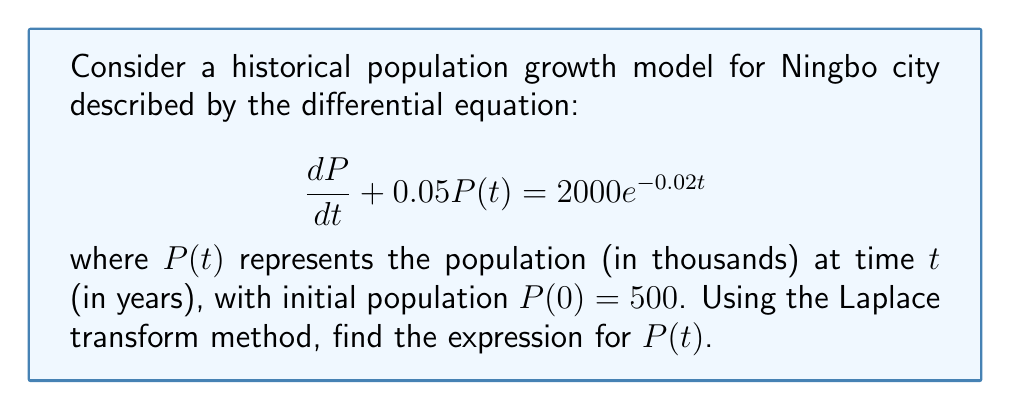Solve this math problem. Let's solve this problem step by step using the Laplace transform method:

1) First, we take the Laplace transform of both sides of the equation:

   $\mathcal{L}\{\frac{dP}{dt} + 0.05P(t)\} = \mathcal{L}\{2000e^{-0.02t}\}$

2) Using the linearity property and the Laplace transform of the derivative:

   $s\mathcal{L}\{P(t)\} - P(0) + 0.05\mathcal{L}\{P(t)\} = \frac{2000}{s+0.02}$

3) Let $\mathcal{L}\{P(t)\} = X(s)$. Substituting the initial condition $P(0) = 500$:

   $sX(s) - 500 + 0.05X(s) = \frac{2000}{s+0.02}$

4) Combining like terms:

   $(s + 0.05)X(s) = 500 + \frac{2000}{s+0.02}$

5) Solving for $X(s)$:

   $X(s) = \frac{500}{s + 0.05} + \frac{2000}{(s + 0.05)(s + 0.02)}$

6) Using partial fraction decomposition on the second term:

   $\frac{2000}{(s + 0.05)(s + 0.02)} = \frac{A}{s + 0.05} + \frac{B}{s + 0.02}$

   where $A = \frac{2000}{0.05 - 0.02} = 66666.67$ and $B = \frac{2000}{0.02 - 0.05} = -66666.67$

7) Therefore:

   $X(s) = \frac{500}{s + 0.05} + \frac{66666.67}{s + 0.05} - \frac{66666.67}{s + 0.02}$

8) Taking the inverse Laplace transform:

   $P(t) = 500e^{-0.05t} + 66666.67e^{-0.05t} - 66666.67e^{-0.02t}$

9) Simplifying:

   $P(t) = 67166.67e^{-0.05t} - 66666.67e^{-0.02t}$

This expression represents the population of Ningbo city (in thousands) at time $t$ (in years) according to the given historical growth model.
Answer: $P(t) = 67166.67e^{-0.05t} - 66666.67e^{-0.02t}$ 